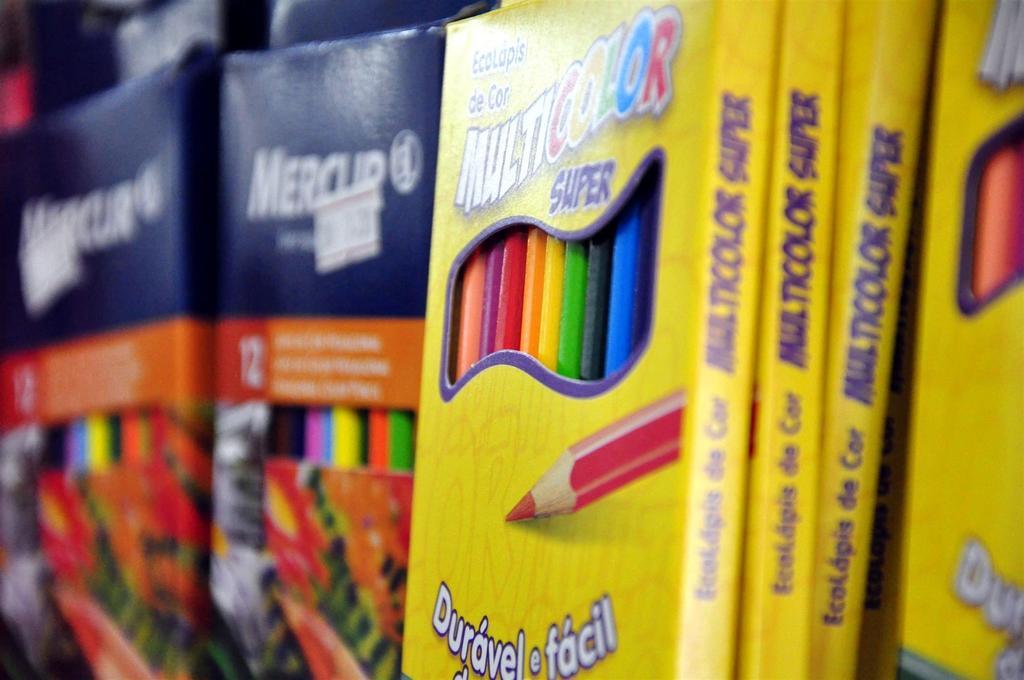What are the adjectives used to describe the colored pencils?
Give a very brief answer. Super. 